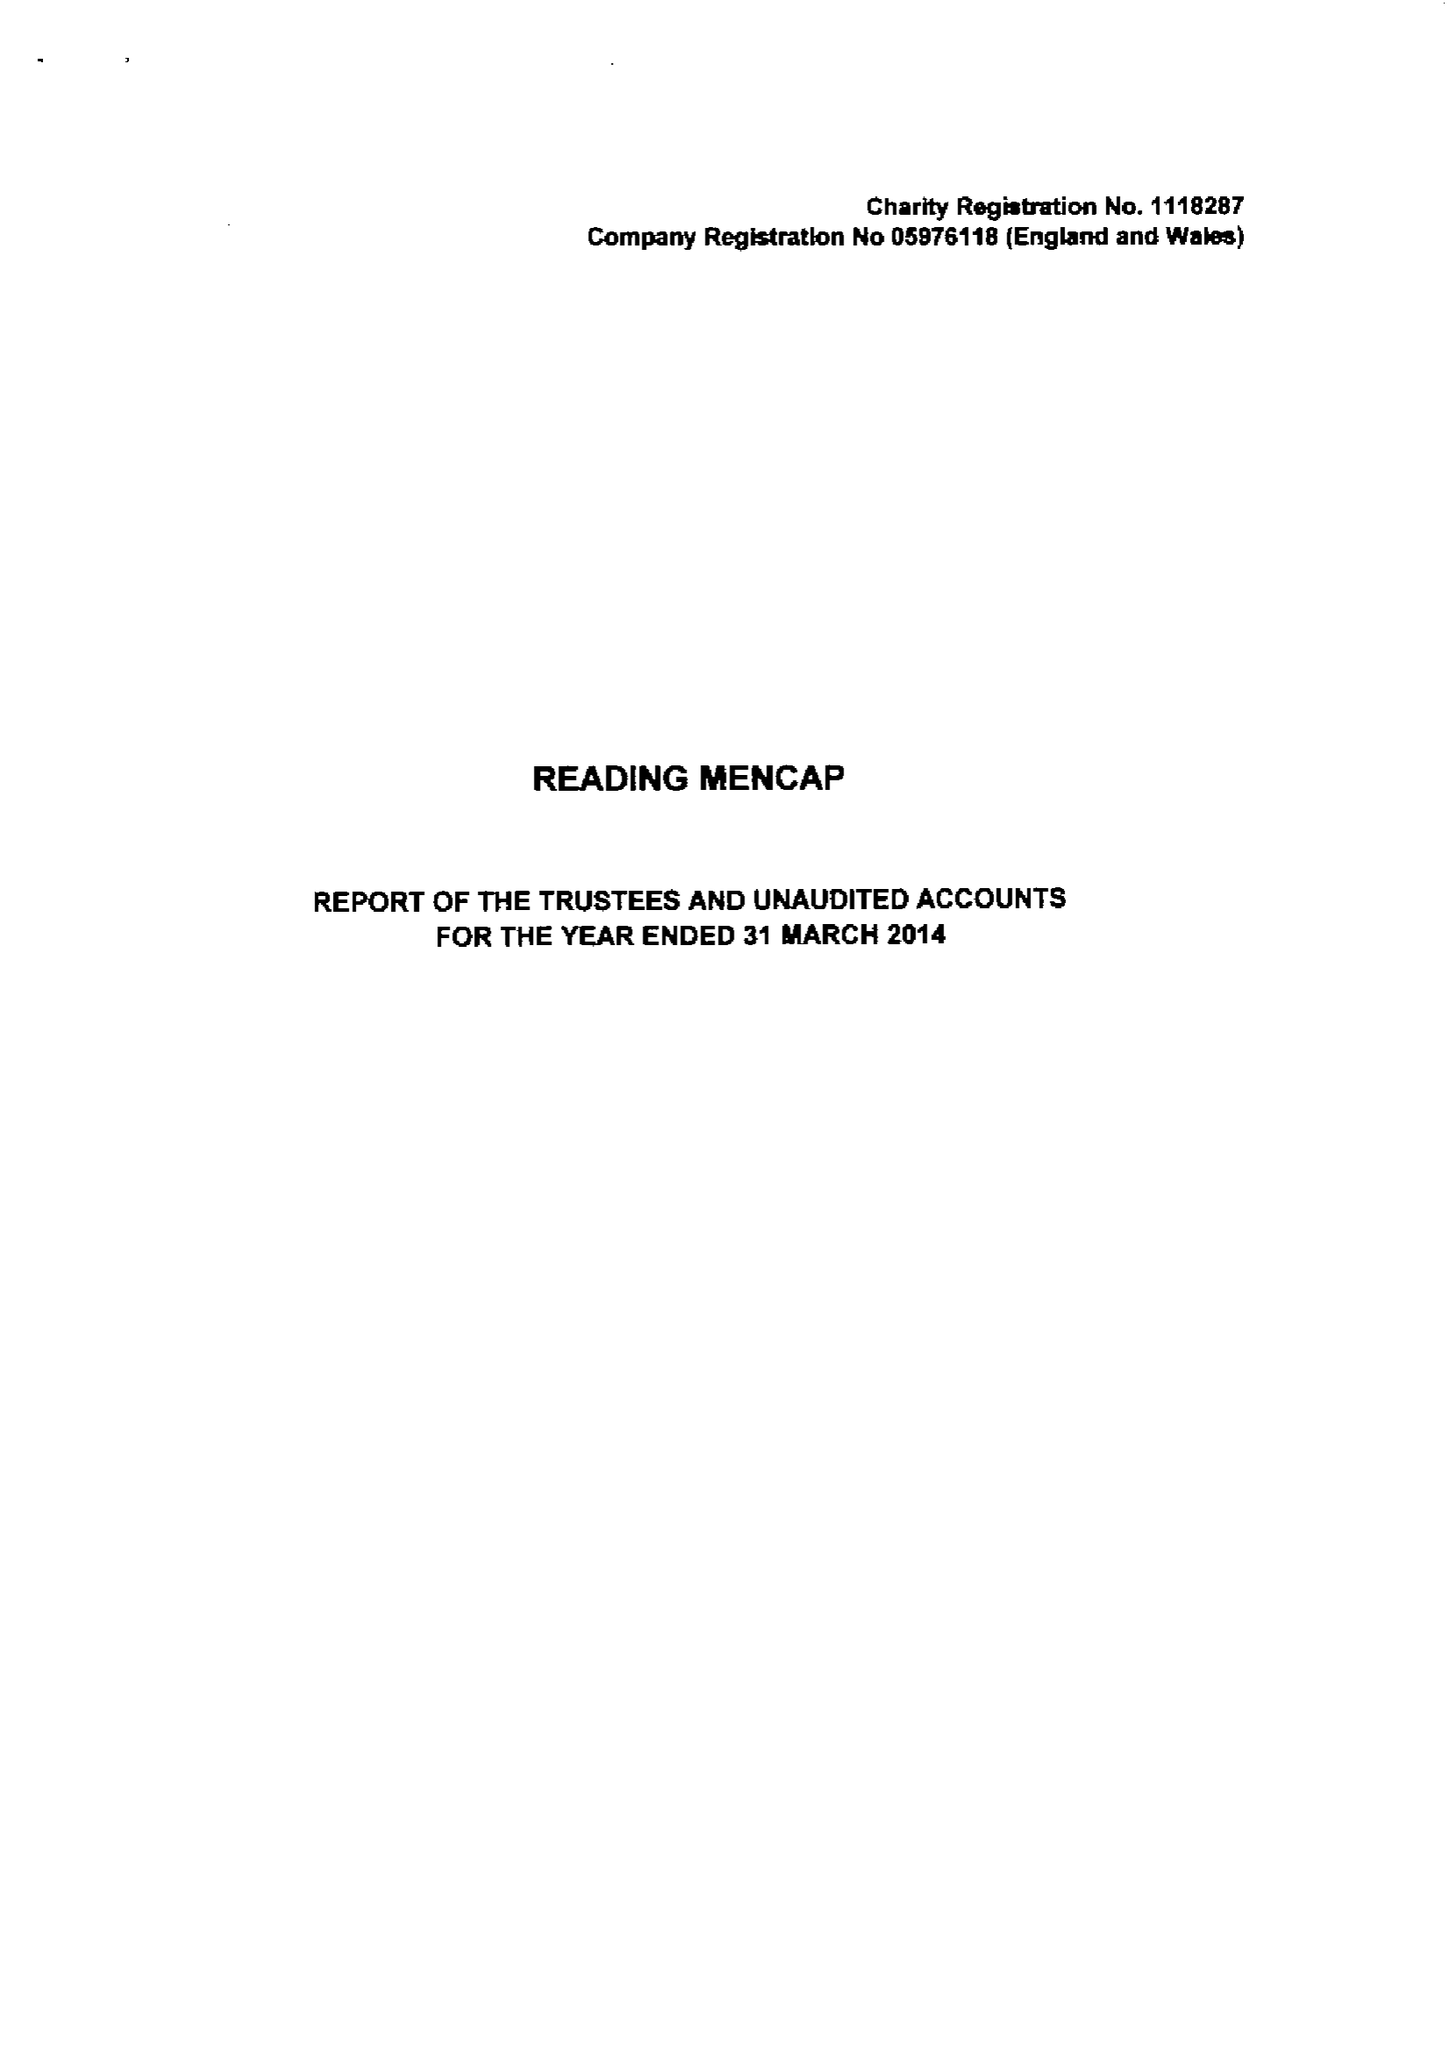What is the value for the charity_number?
Answer the question using a single word or phrase. 1118287 